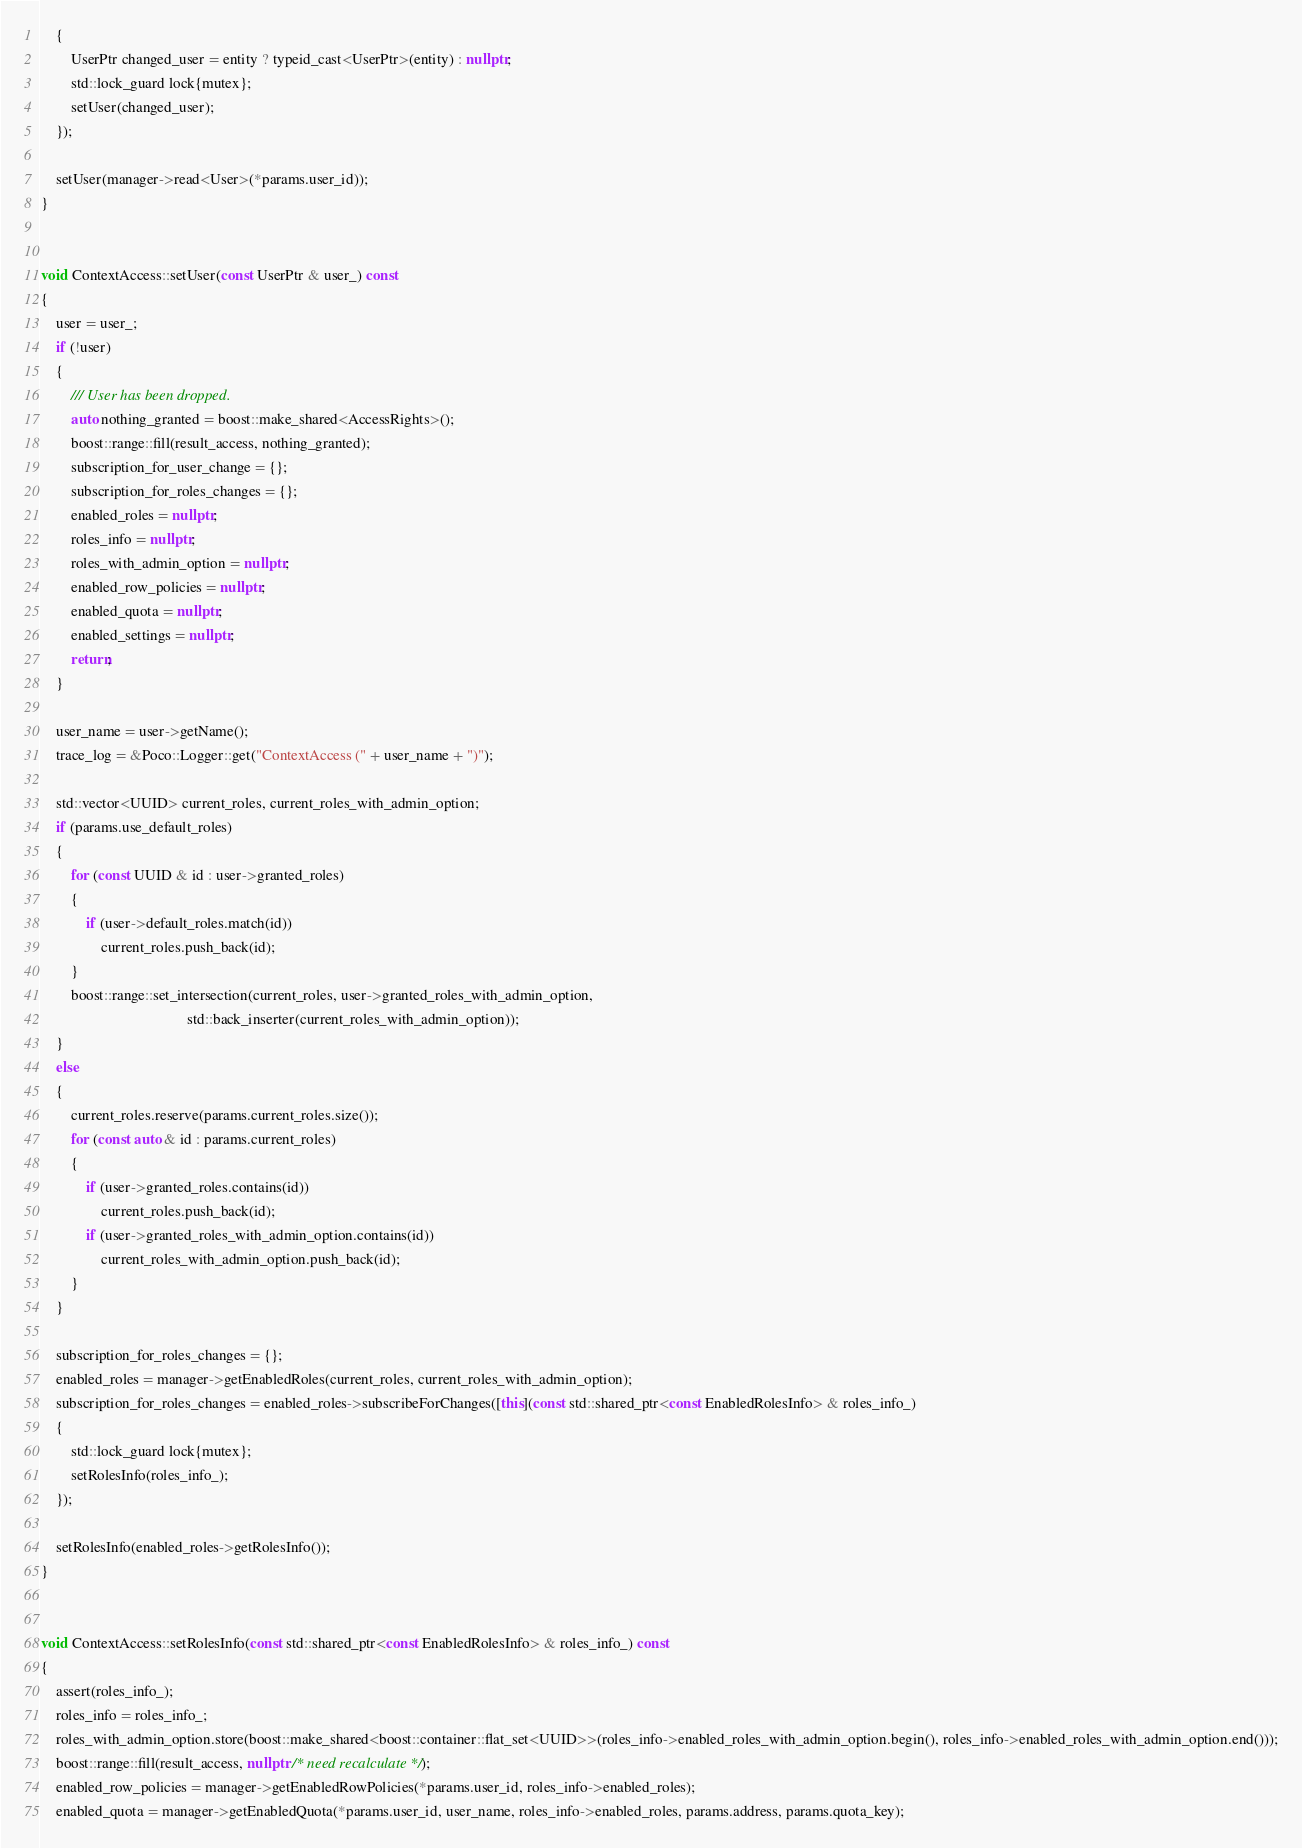Convert code to text. <code><loc_0><loc_0><loc_500><loc_500><_C++_>    {
        UserPtr changed_user = entity ? typeid_cast<UserPtr>(entity) : nullptr;
        std::lock_guard lock{mutex};
        setUser(changed_user);
    });

    setUser(manager->read<User>(*params.user_id));
}


void ContextAccess::setUser(const UserPtr & user_) const
{
    user = user_;
    if (!user)
    {
        /// User has been dropped.
        auto nothing_granted = boost::make_shared<AccessRights>();
        boost::range::fill(result_access, nothing_granted);
        subscription_for_user_change = {};
        subscription_for_roles_changes = {};
        enabled_roles = nullptr;
        roles_info = nullptr;
        roles_with_admin_option = nullptr;
        enabled_row_policies = nullptr;
        enabled_quota = nullptr;
        enabled_settings = nullptr;
        return;
    }

    user_name = user->getName();
    trace_log = &Poco::Logger::get("ContextAccess (" + user_name + ")");

    std::vector<UUID> current_roles, current_roles_with_admin_option;
    if (params.use_default_roles)
    {
        for (const UUID & id : user->granted_roles)
        {
            if (user->default_roles.match(id))
                current_roles.push_back(id);
        }
        boost::range::set_intersection(current_roles, user->granted_roles_with_admin_option,
                                       std::back_inserter(current_roles_with_admin_option));
    }
    else
    {
        current_roles.reserve(params.current_roles.size());
        for (const auto & id : params.current_roles)
        {
            if (user->granted_roles.contains(id))
                current_roles.push_back(id);
            if (user->granted_roles_with_admin_option.contains(id))
                current_roles_with_admin_option.push_back(id);
        }
    }

    subscription_for_roles_changes = {};
    enabled_roles = manager->getEnabledRoles(current_roles, current_roles_with_admin_option);
    subscription_for_roles_changes = enabled_roles->subscribeForChanges([this](const std::shared_ptr<const EnabledRolesInfo> & roles_info_)
    {
        std::lock_guard lock{mutex};
        setRolesInfo(roles_info_);
    });

    setRolesInfo(enabled_roles->getRolesInfo());
}


void ContextAccess::setRolesInfo(const std::shared_ptr<const EnabledRolesInfo> & roles_info_) const
{
    assert(roles_info_);
    roles_info = roles_info_;
    roles_with_admin_option.store(boost::make_shared<boost::container::flat_set<UUID>>(roles_info->enabled_roles_with_admin_option.begin(), roles_info->enabled_roles_with_admin_option.end()));
    boost::range::fill(result_access, nullptr /* need recalculate */);
    enabled_row_policies = manager->getEnabledRowPolicies(*params.user_id, roles_info->enabled_roles);
    enabled_quota = manager->getEnabledQuota(*params.user_id, user_name, roles_info->enabled_roles, params.address, params.quota_key);</code> 